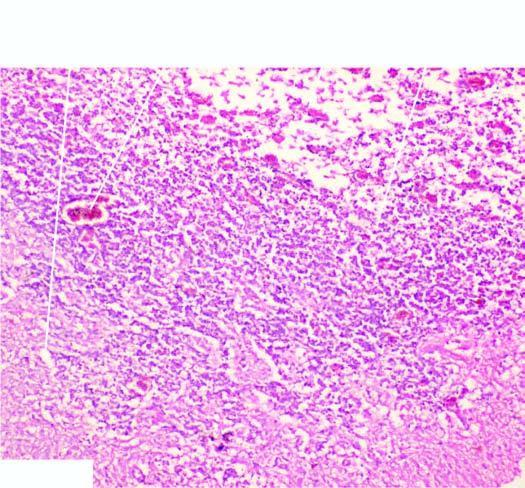re the histologic changes reactive astrocytosis, a few reactive macrophages and neovascularisation in the wall of the cystic lesion?
Answer the question using a single word or phrase. Yes 